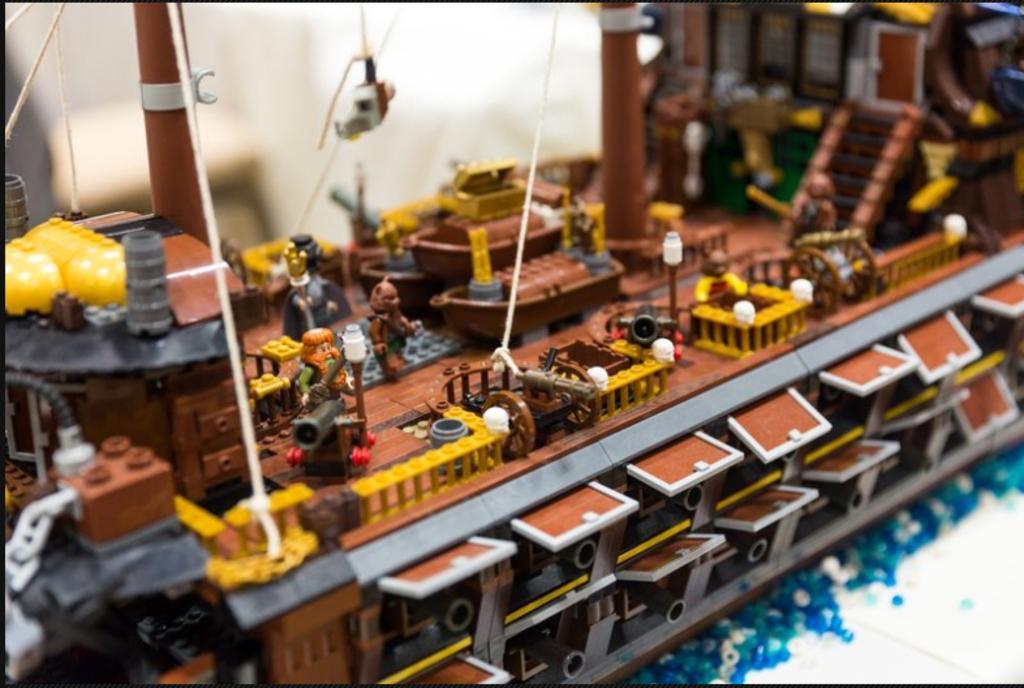In one or two sentences, can you explain what this image depicts? In this picture we can see toys made of building blocks, threads and in the background it is blurry. 